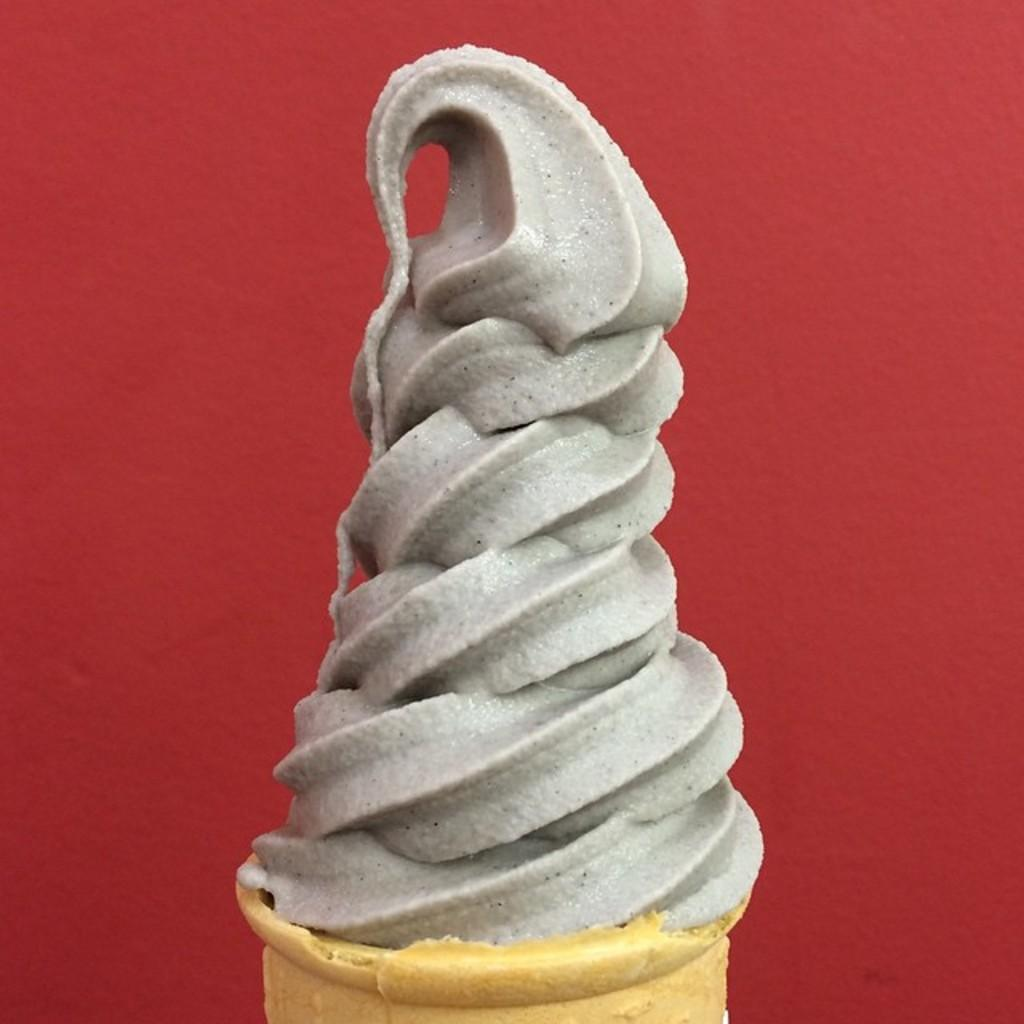What is the main subject of the picture? The main subject of the picture is an ice cream. How is the ice cream being served? The ice cream is on a cone wafer. What color is the background of the image? The background of the image is red. What type of fowl can be seen in the image? There are no fowl present in the image; it features an ice cream on a cone wafer with a red background. How does the ice cream feel about being eaten in the image? The ice cream is an inanimate object and does not have feelings or emotions, so it cannot feel shame or any other emotion. 